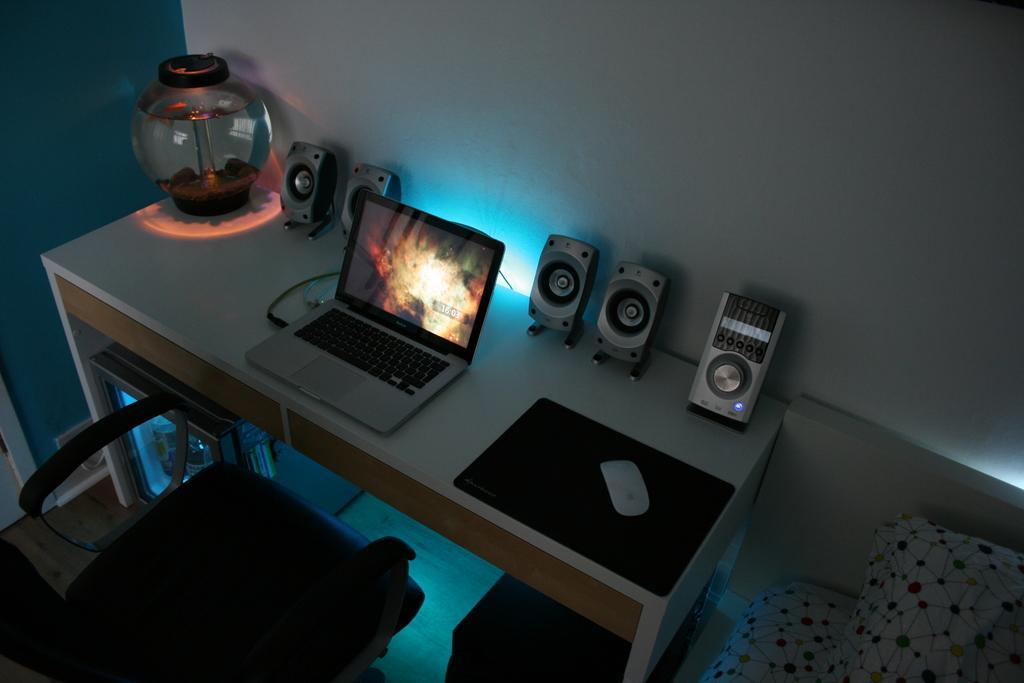Describe this image in one or two sentences. As we can see in the image there is a wall, chair and table. On table there is a pot, laptop, mouse and a mat. 